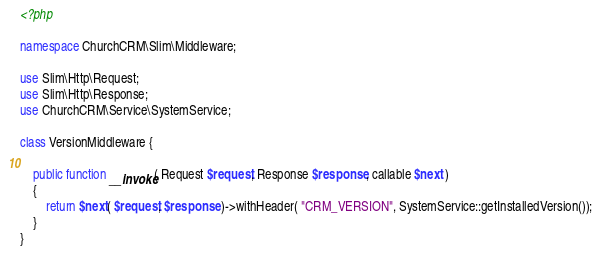<code> <loc_0><loc_0><loc_500><loc_500><_PHP_><?php

namespace ChurchCRM\Slim\Middleware;

use Slim\Http\Request;
use Slim\Http\Response;
use ChurchCRM\Service\SystemService;

class VersionMiddleware {

	public function __invoke( Request $request, Response $response, callable $next )
	{
		return $next( $request, $response )->withHeader( "CRM_VERSION", SystemService::getInstalledVersion());
	}
}</code> 